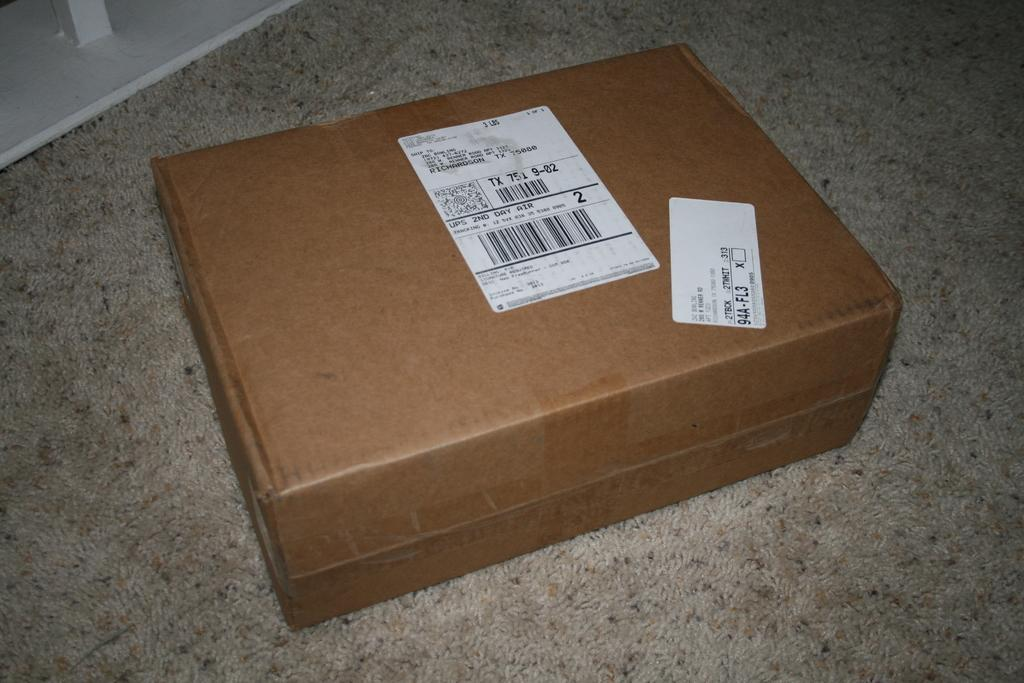<image>
Create a compact narrative representing the image presented. A package shipped via UPS 2nd Day Air to Richmond, Texas. 